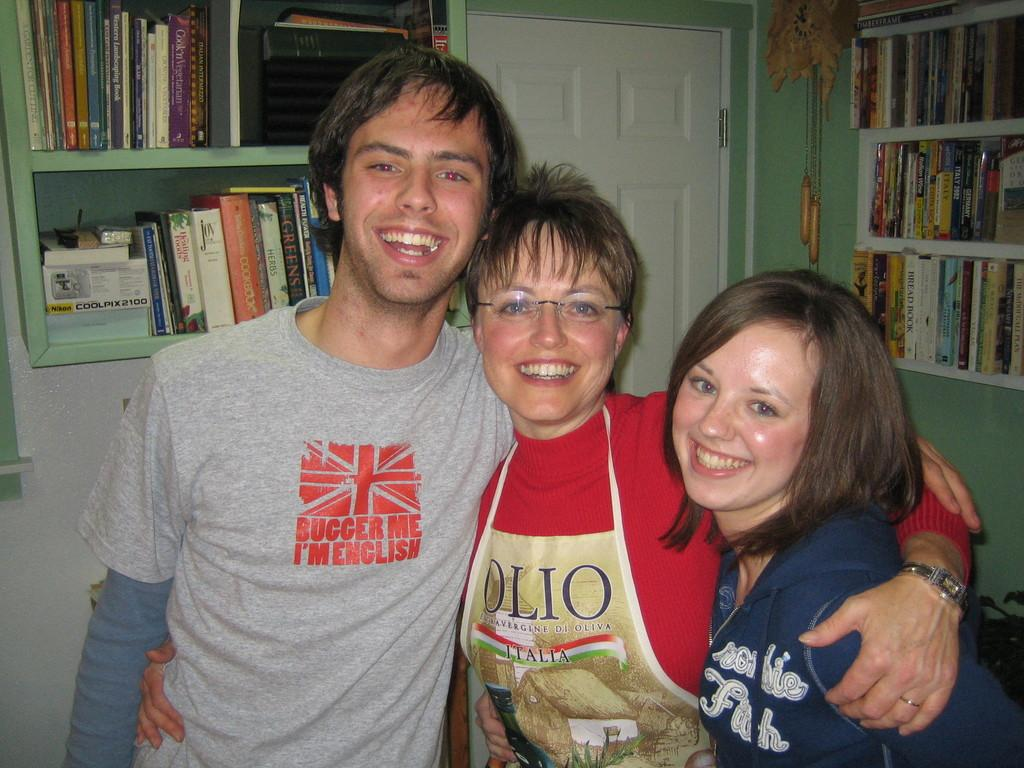What is the general activity of the people in the image? There are people standing in the image, which suggests they might be waiting or gathered for a specific purpose. Can you describe the attire of one of the individuals? A woman is wearing an apron, which might indicate that she is involved in cooking or serving food. What type of furniture or structure can be seen in the image? Bookshelves are visible in the image, which suggests that the setting might be a library, study, or home with a collection of books. How does the lift function in the image? There is no lift present in the image; it features people standing and a woman wearing an apron in a setting with bookshelves. 